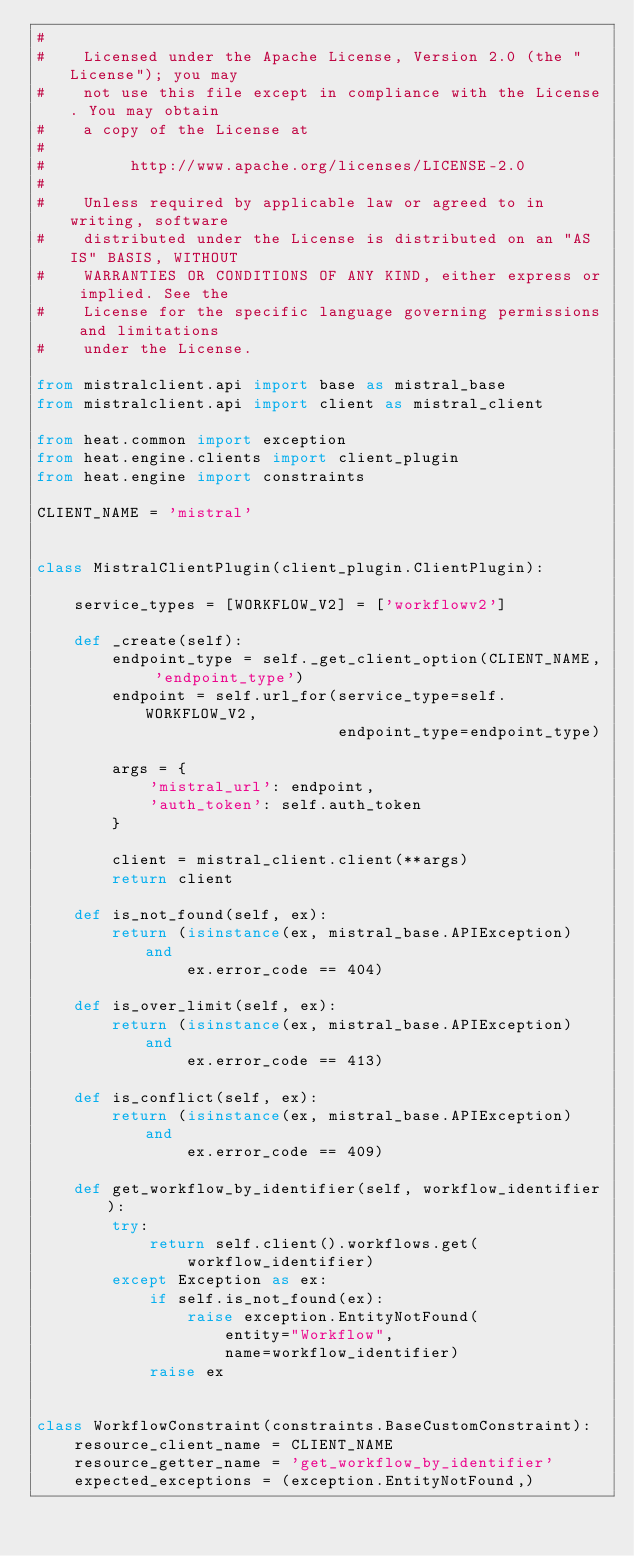Convert code to text. <code><loc_0><loc_0><loc_500><loc_500><_Python_>#
#    Licensed under the Apache License, Version 2.0 (the "License"); you may
#    not use this file except in compliance with the License. You may obtain
#    a copy of the License at
#
#         http://www.apache.org/licenses/LICENSE-2.0
#
#    Unless required by applicable law or agreed to in writing, software
#    distributed under the License is distributed on an "AS IS" BASIS, WITHOUT
#    WARRANTIES OR CONDITIONS OF ANY KIND, either express or implied. See the
#    License for the specific language governing permissions and limitations
#    under the License.

from mistralclient.api import base as mistral_base
from mistralclient.api import client as mistral_client

from heat.common import exception
from heat.engine.clients import client_plugin
from heat.engine import constraints

CLIENT_NAME = 'mistral'


class MistralClientPlugin(client_plugin.ClientPlugin):

    service_types = [WORKFLOW_V2] = ['workflowv2']

    def _create(self):
        endpoint_type = self._get_client_option(CLIENT_NAME, 'endpoint_type')
        endpoint = self.url_for(service_type=self.WORKFLOW_V2,
                                endpoint_type=endpoint_type)

        args = {
            'mistral_url': endpoint,
            'auth_token': self.auth_token
        }

        client = mistral_client.client(**args)
        return client

    def is_not_found(self, ex):
        return (isinstance(ex, mistral_base.APIException) and
                ex.error_code == 404)

    def is_over_limit(self, ex):
        return (isinstance(ex, mistral_base.APIException) and
                ex.error_code == 413)

    def is_conflict(self, ex):
        return (isinstance(ex, mistral_base.APIException) and
                ex.error_code == 409)

    def get_workflow_by_identifier(self, workflow_identifier):
        try:
            return self.client().workflows.get(
                workflow_identifier)
        except Exception as ex:
            if self.is_not_found(ex):
                raise exception.EntityNotFound(
                    entity="Workflow",
                    name=workflow_identifier)
            raise ex


class WorkflowConstraint(constraints.BaseCustomConstraint):
    resource_client_name = CLIENT_NAME
    resource_getter_name = 'get_workflow_by_identifier'
    expected_exceptions = (exception.EntityNotFound,)
</code> 